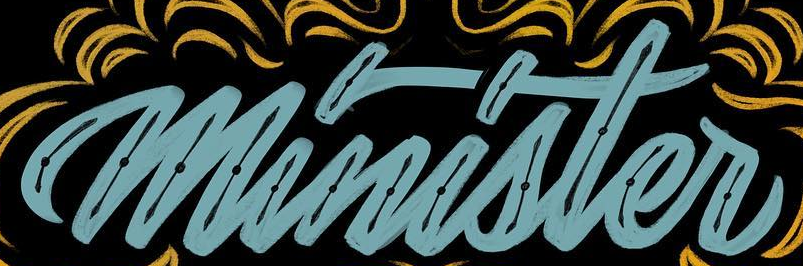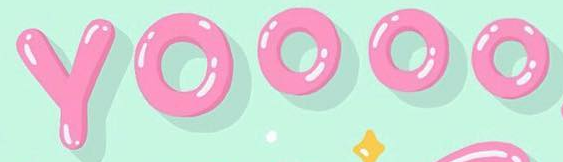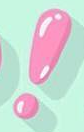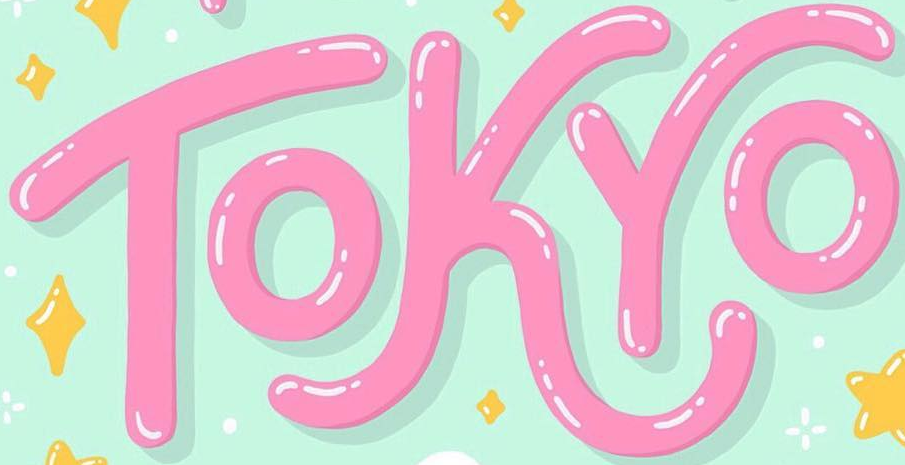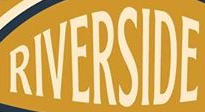What text is displayed in these images sequentially, separated by a semicolon? minister; YOOOO; !; TOKYO; RIVERSIDE 